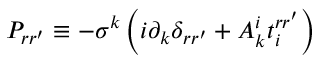Convert formula to latex. <formula><loc_0><loc_0><loc_500><loc_500>P _ { r r ^ { \prime } } \equiv - \sigma ^ { k } \left ( i \partial _ { k } \delta _ { r r ^ { \prime } } + A _ { k } ^ { i } t _ { i } ^ { r r ^ { \prime } } \right )</formula> 